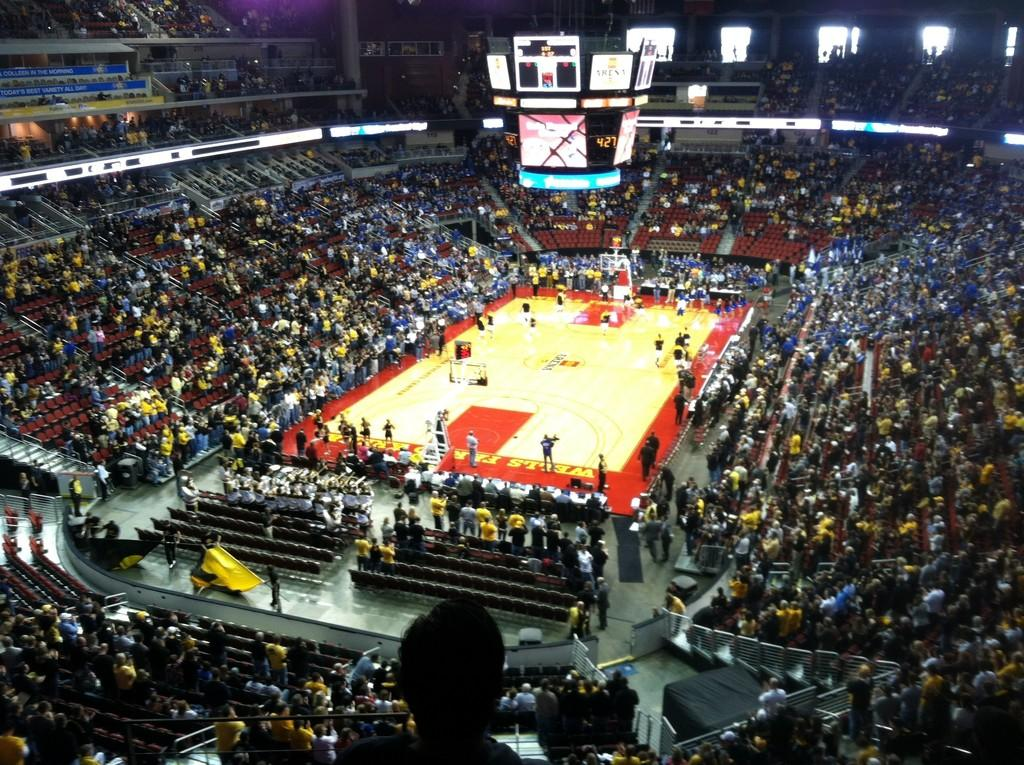<image>
Provide a brief description of the given image. Inside of a large arena, a basketball court displays advertising from Wells Fargo Bank. 